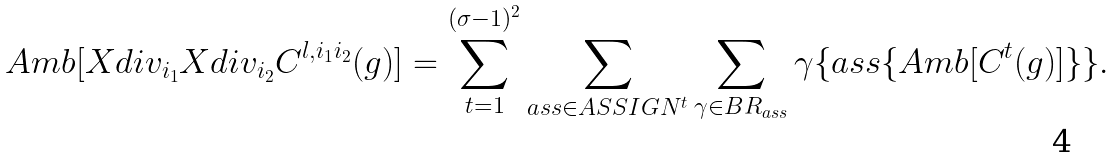<formula> <loc_0><loc_0><loc_500><loc_500>A m b [ X d i v _ { i _ { 1 } } X d i v _ { i _ { 2 } } C ^ { l , i _ { 1 } i _ { 2 } } ( g ) ] = \sum _ { t = 1 } ^ { ( \sigma - 1 ) ^ { 2 } } \sum _ { a s s \in A S S I G N ^ { t } } \sum _ { \gamma \in B R _ { a s s } } \gamma \{ a s s \{ A m b [ C ^ { t } ( g ) ] \} \} .</formula> 